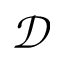<formula> <loc_0><loc_0><loc_500><loc_500>\mathcal { D }</formula> 